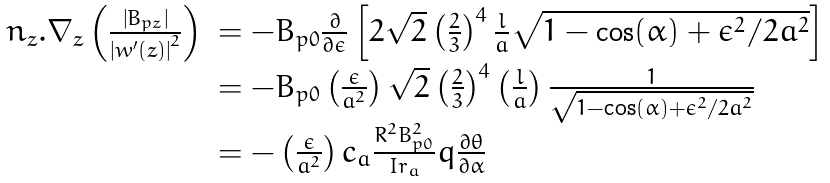<formula> <loc_0><loc_0><loc_500><loc_500>\begin{array} { l l } n _ { z } . \nabla _ { z } \left ( \frac { \left | B _ { p z } \right | } { \left | w ^ { \prime } ( z ) \right | ^ { 2 } } \right ) & = - B _ { p 0 } \frac { \partial } { \partial \epsilon } \left [ 2 \sqrt { 2 } \left ( \frac { 2 } { 3 } \right ) ^ { 4 } \frac { l } { a } \sqrt { 1 - \cos ( \alpha ) + \epsilon ^ { 2 } / 2 a ^ { 2 } } \right ] \\ & = - B _ { p 0 } \left ( \frac { \epsilon } { a ^ { 2 } } \right ) \sqrt { 2 } \left ( \frac { 2 } { 3 } \right ) ^ { 4 } \left ( \frac { l } { a } \right ) \frac { 1 } { \sqrt { 1 - \cos ( \alpha ) + \epsilon ^ { 2 } / 2 a ^ { 2 } } } \\ & = - \left ( \frac { \epsilon } { a ^ { 2 } } \right ) c _ { a } \frac { R ^ { 2 } B _ { p 0 } ^ { 2 } } { I r _ { a } } q \frac { \partial \theta } { \partial \alpha } \end{array}</formula> 